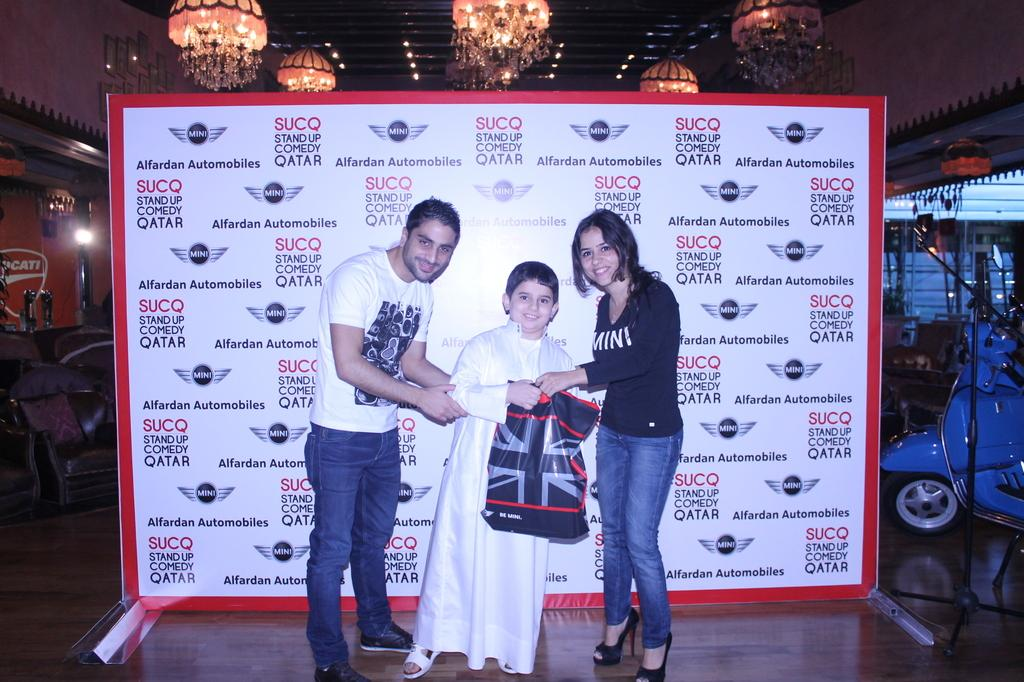Provide a one-sentence caption for the provided image. Two adults and a child stand in front of a board with an automobile logo on it. 